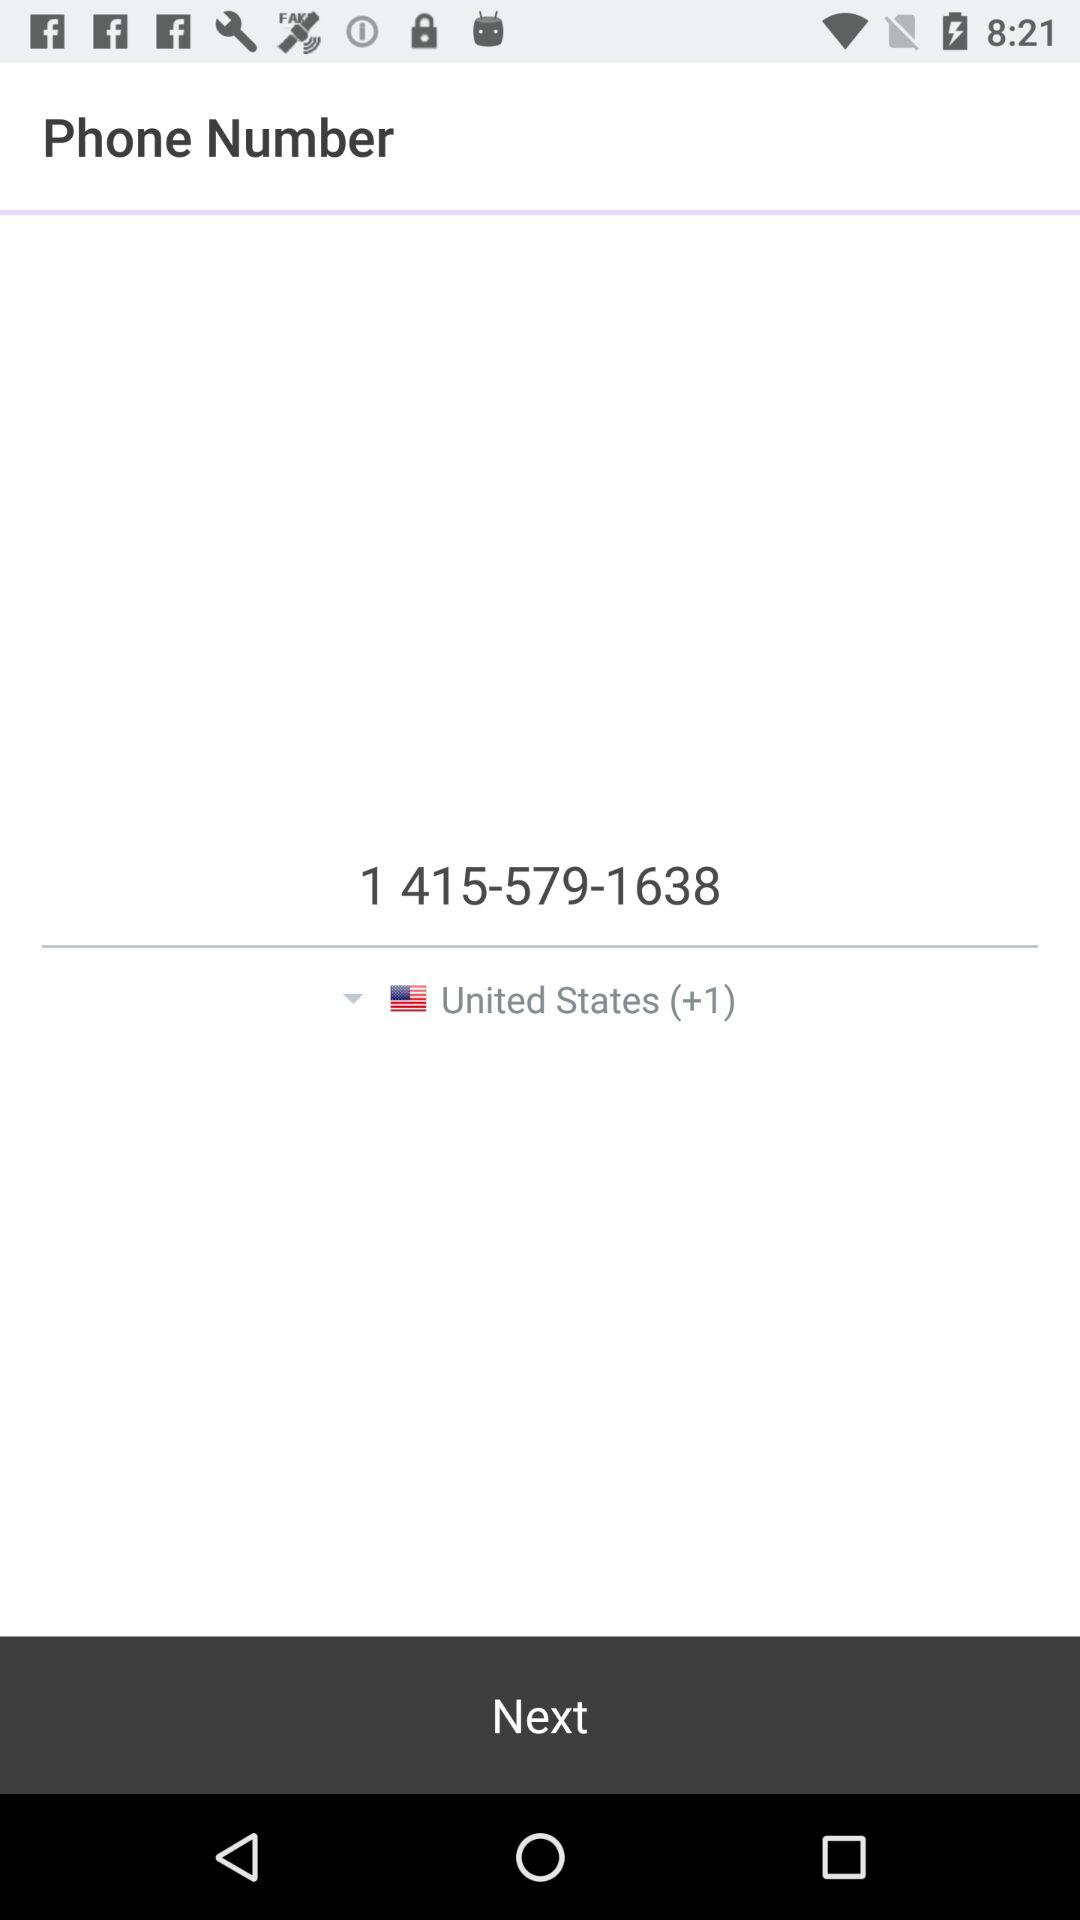What is the country code for the United States? The country code for the United States is +1. 